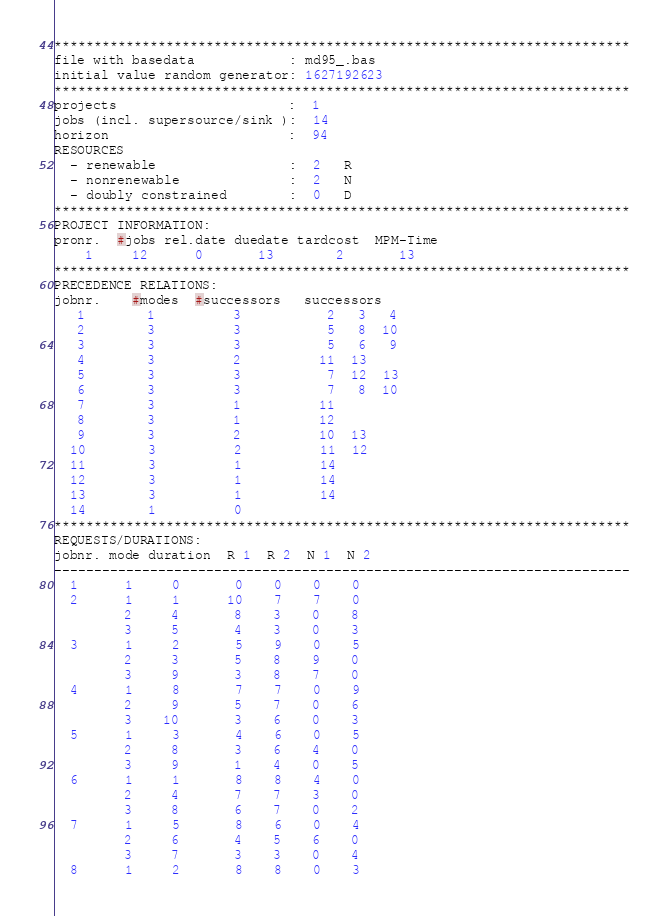Convert code to text. <code><loc_0><loc_0><loc_500><loc_500><_ObjectiveC_>************************************************************************
file with basedata            : md95_.bas
initial value random generator: 1627192623
************************************************************************
projects                      :  1
jobs (incl. supersource/sink ):  14
horizon                       :  94
RESOURCES
  - renewable                 :  2   R
  - nonrenewable              :  2   N
  - doubly constrained        :  0   D
************************************************************************
PROJECT INFORMATION:
pronr.  #jobs rel.date duedate tardcost  MPM-Time
    1     12      0       13        2       13
************************************************************************
PRECEDENCE RELATIONS:
jobnr.    #modes  #successors   successors
   1        1          3           2   3   4
   2        3          3           5   8  10
   3        3          3           5   6   9
   4        3          2          11  13
   5        3          3           7  12  13
   6        3          3           7   8  10
   7        3          1          11
   8        3          1          12
   9        3          2          10  13
  10        3          2          11  12
  11        3          1          14
  12        3          1          14
  13        3          1          14
  14        1          0        
************************************************************************
REQUESTS/DURATIONS:
jobnr. mode duration  R 1  R 2  N 1  N 2
------------------------------------------------------------------------
  1      1     0       0    0    0    0
  2      1     1      10    7    7    0
         2     4       8    3    0    8
         3     5       4    3    0    3
  3      1     2       5    9    0    5
         2     3       5    8    9    0
         3     9       3    8    7    0
  4      1     8       7    7    0    9
         2     9       5    7    0    6
         3    10       3    6    0    3
  5      1     3       4    6    0    5
         2     8       3    6    4    0
         3     9       1    4    0    5
  6      1     1       8    8    4    0
         2     4       7    7    3    0
         3     8       6    7    0    2
  7      1     5       8    6    0    4
         2     6       4    5    6    0
         3     7       3    3    0    4
  8      1     2       8    8    0    3</code> 